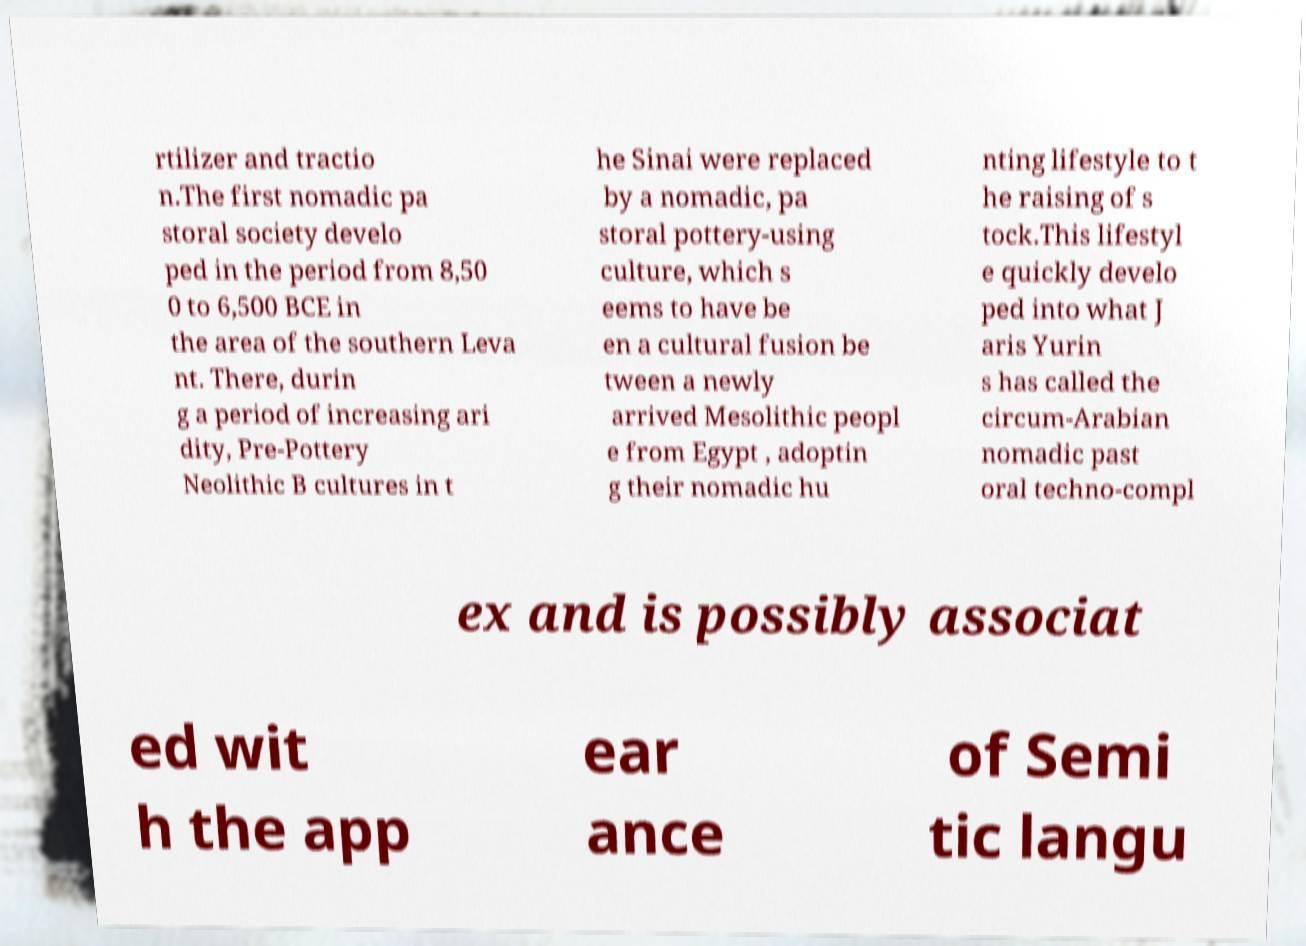Can you accurately transcribe the text from the provided image for me? rtilizer and tractio n.The first nomadic pa storal society develo ped in the period from 8,50 0 to 6,500 BCE in the area of the southern Leva nt. There, durin g a period of increasing ari dity, Pre-Pottery Neolithic B cultures in t he Sinai were replaced by a nomadic, pa storal pottery-using culture, which s eems to have be en a cultural fusion be tween a newly arrived Mesolithic peopl e from Egypt , adoptin g their nomadic hu nting lifestyle to t he raising of s tock.This lifestyl e quickly develo ped into what J aris Yurin s has called the circum-Arabian nomadic past oral techno-compl ex and is possibly associat ed wit h the app ear ance of Semi tic langu 